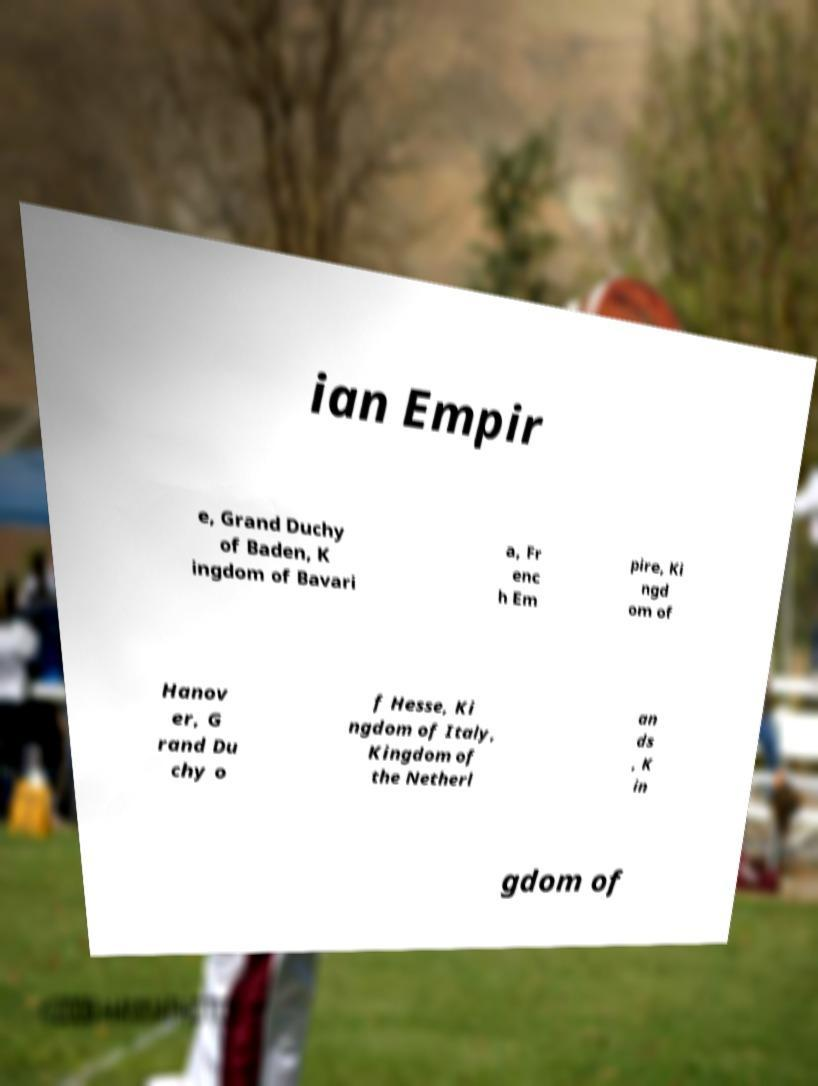There's text embedded in this image that I need extracted. Can you transcribe it verbatim? ian Empir e, Grand Duchy of Baden, K ingdom of Bavari a, Fr enc h Em pire, Ki ngd om of Hanov er, G rand Du chy o f Hesse, Ki ngdom of Italy, Kingdom of the Netherl an ds , K in gdom of 